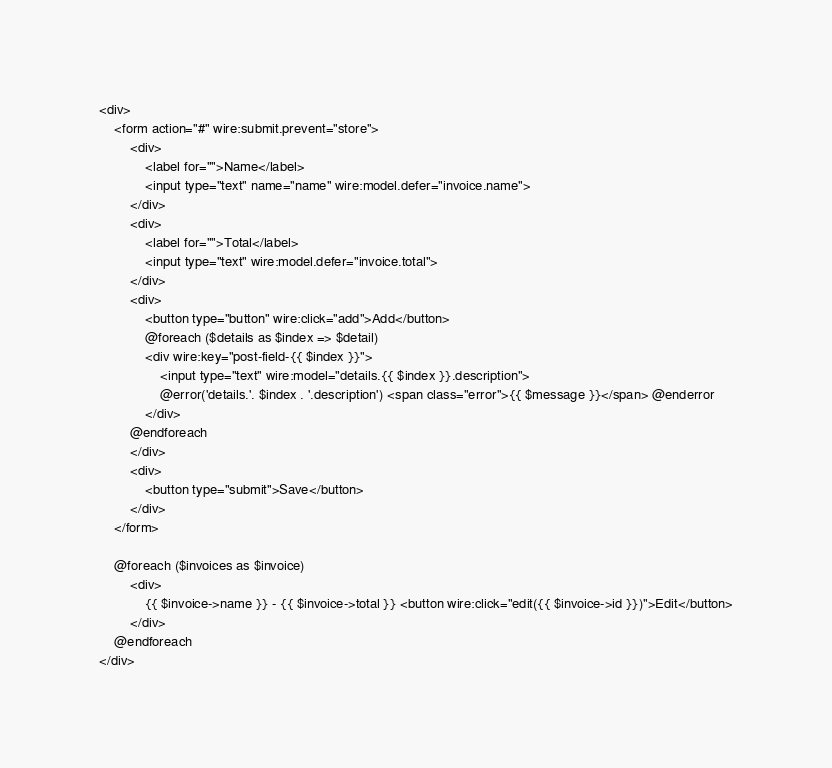<code> <loc_0><loc_0><loc_500><loc_500><_PHP_><div>
    <form action="#" wire:submit.prevent="store">
        <div>
            <label for="">Name</label>
            <input type="text" name="name" wire:model.defer="invoice.name">
        </div>
        <div>
            <label for="">Total</label>
            <input type="text" wire:model.defer="invoice.total">
        </div>
        <div>
            <button type="button" wire:click="add">Add</button>
            @foreach ($details as $index => $detail)
            <div wire:key="post-field-{{ $index }}">
                <input type="text" wire:model="details.{{ $index }}.description">
                @error('details.'. $index . '.description') <span class="error">{{ $message }}</span> @enderror
            </div>
        @endforeach
        </div>
        <div>
            <button type="submit">Save</button>
        </div>
    </form>

    @foreach ($invoices as $invoice)
        <div>
            {{ $invoice->name }} - {{ $invoice->total }} <button wire:click="edit({{ $invoice->id }})">Edit</button>
        </div>
    @endforeach
</div>
</code> 